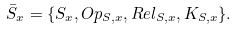<formula> <loc_0><loc_0><loc_500><loc_500>\bar { S } _ { x } = \{ S _ { x } , O p _ { S , x } , R e l _ { S , x } , K _ { S , x } \} .</formula> 